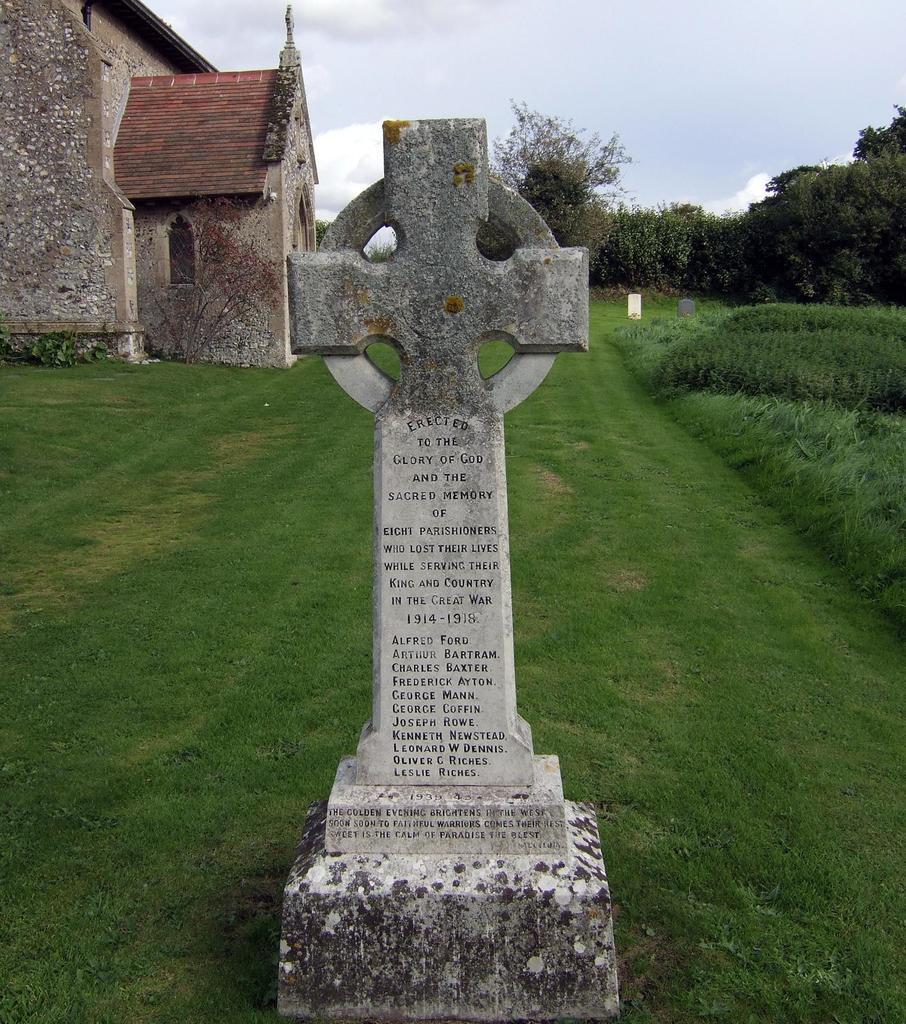Please provide a concise description of this image. In the middle of the image we can see a headstone, in the background we can see grass, a house, plants and trees. 